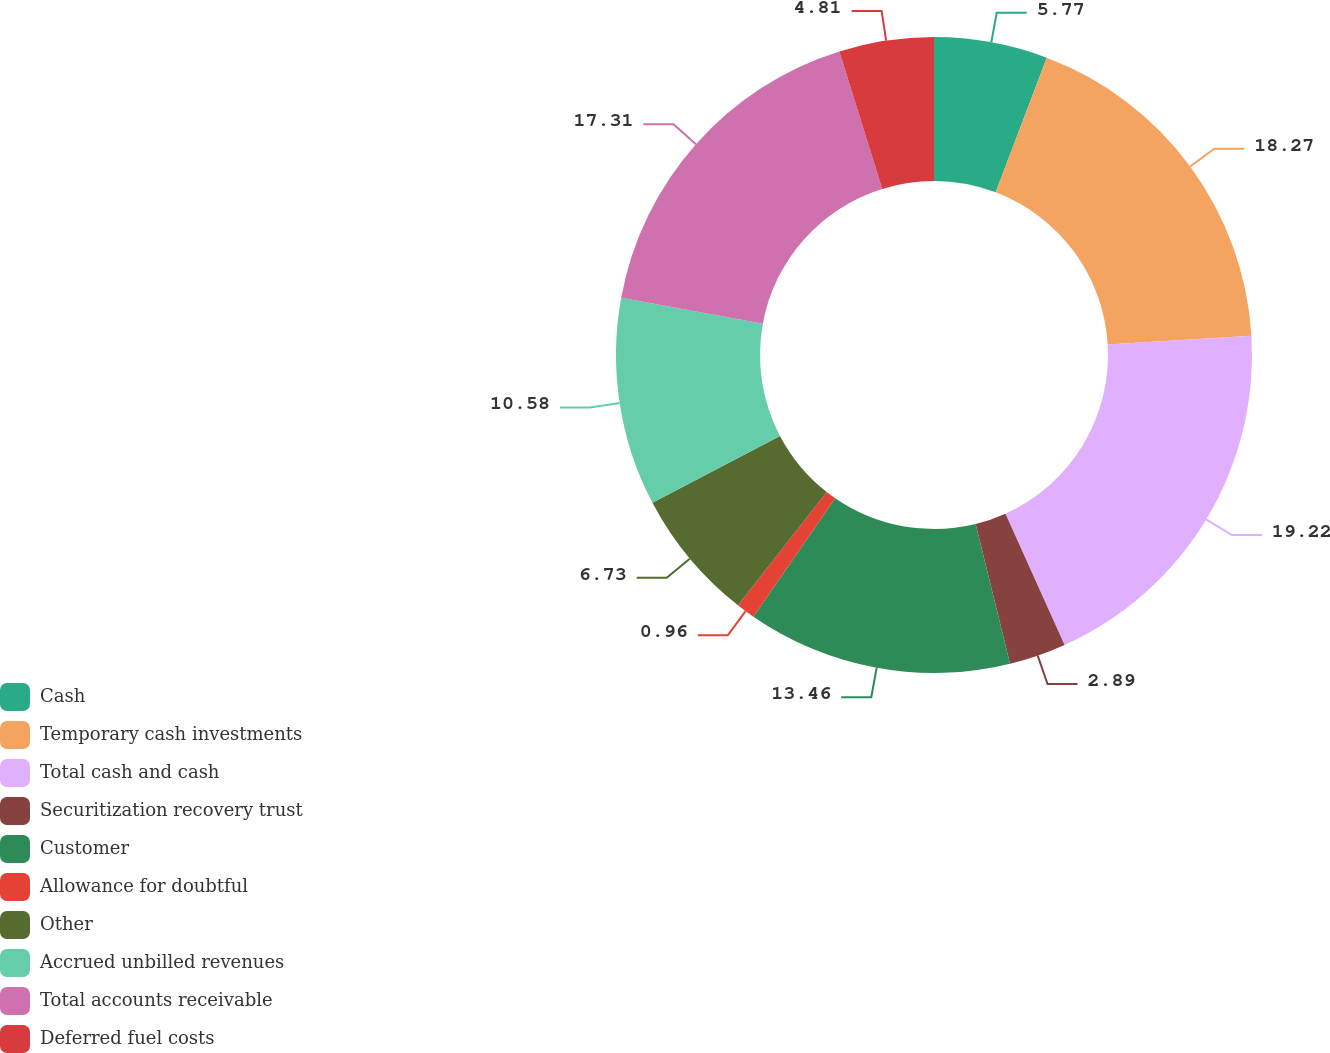Convert chart to OTSL. <chart><loc_0><loc_0><loc_500><loc_500><pie_chart><fcel>Cash<fcel>Temporary cash investments<fcel>Total cash and cash<fcel>Securitization recovery trust<fcel>Customer<fcel>Allowance for doubtful<fcel>Other<fcel>Accrued unbilled revenues<fcel>Total accounts receivable<fcel>Deferred fuel costs<nl><fcel>5.77%<fcel>18.27%<fcel>19.23%<fcel>2.89%<fcel>13.46%<fcel>0.96%<fcel>6.73%<fcel>10.58%<fcel>17.31%<fcel>4.81%<nl></chart> 